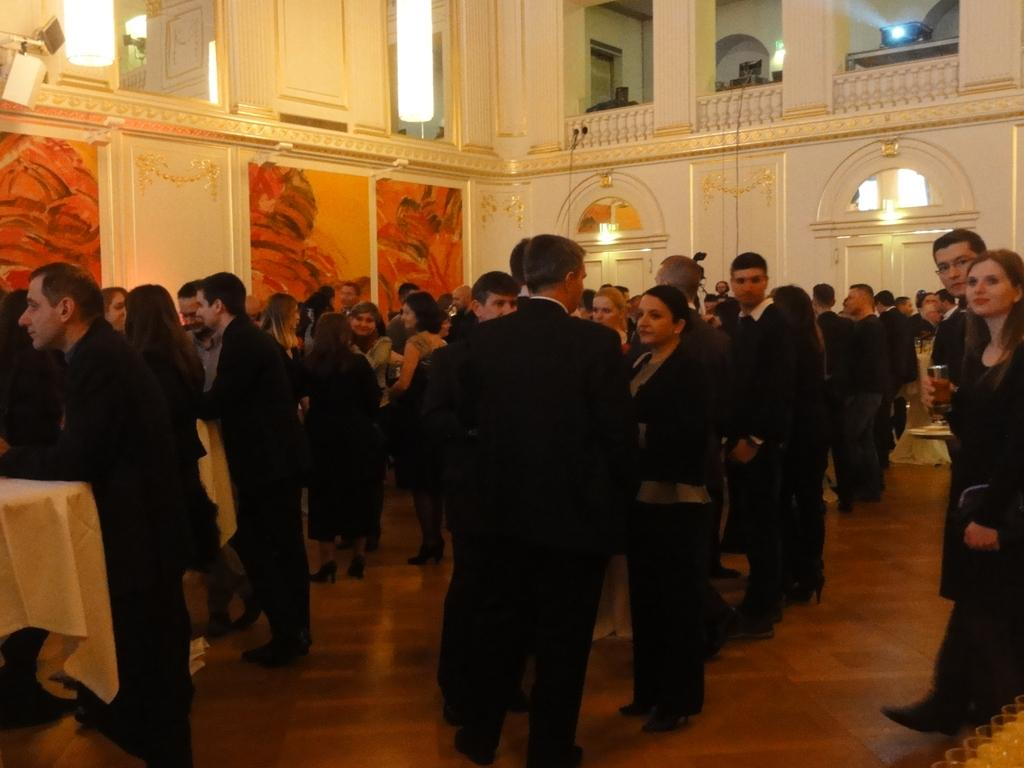How many people are in the image? There is a group of people in the image, but the exact number is not specified. What are the people doing in the image? The people are standing on the floor. What can be seen behind the people in the image? There is a wall with lights behind the people. What type of wren can be seen perched on the string in the image? There is no wren or string present in the image. What sound does the alarm make in the image? There is no alarm present in the image. 